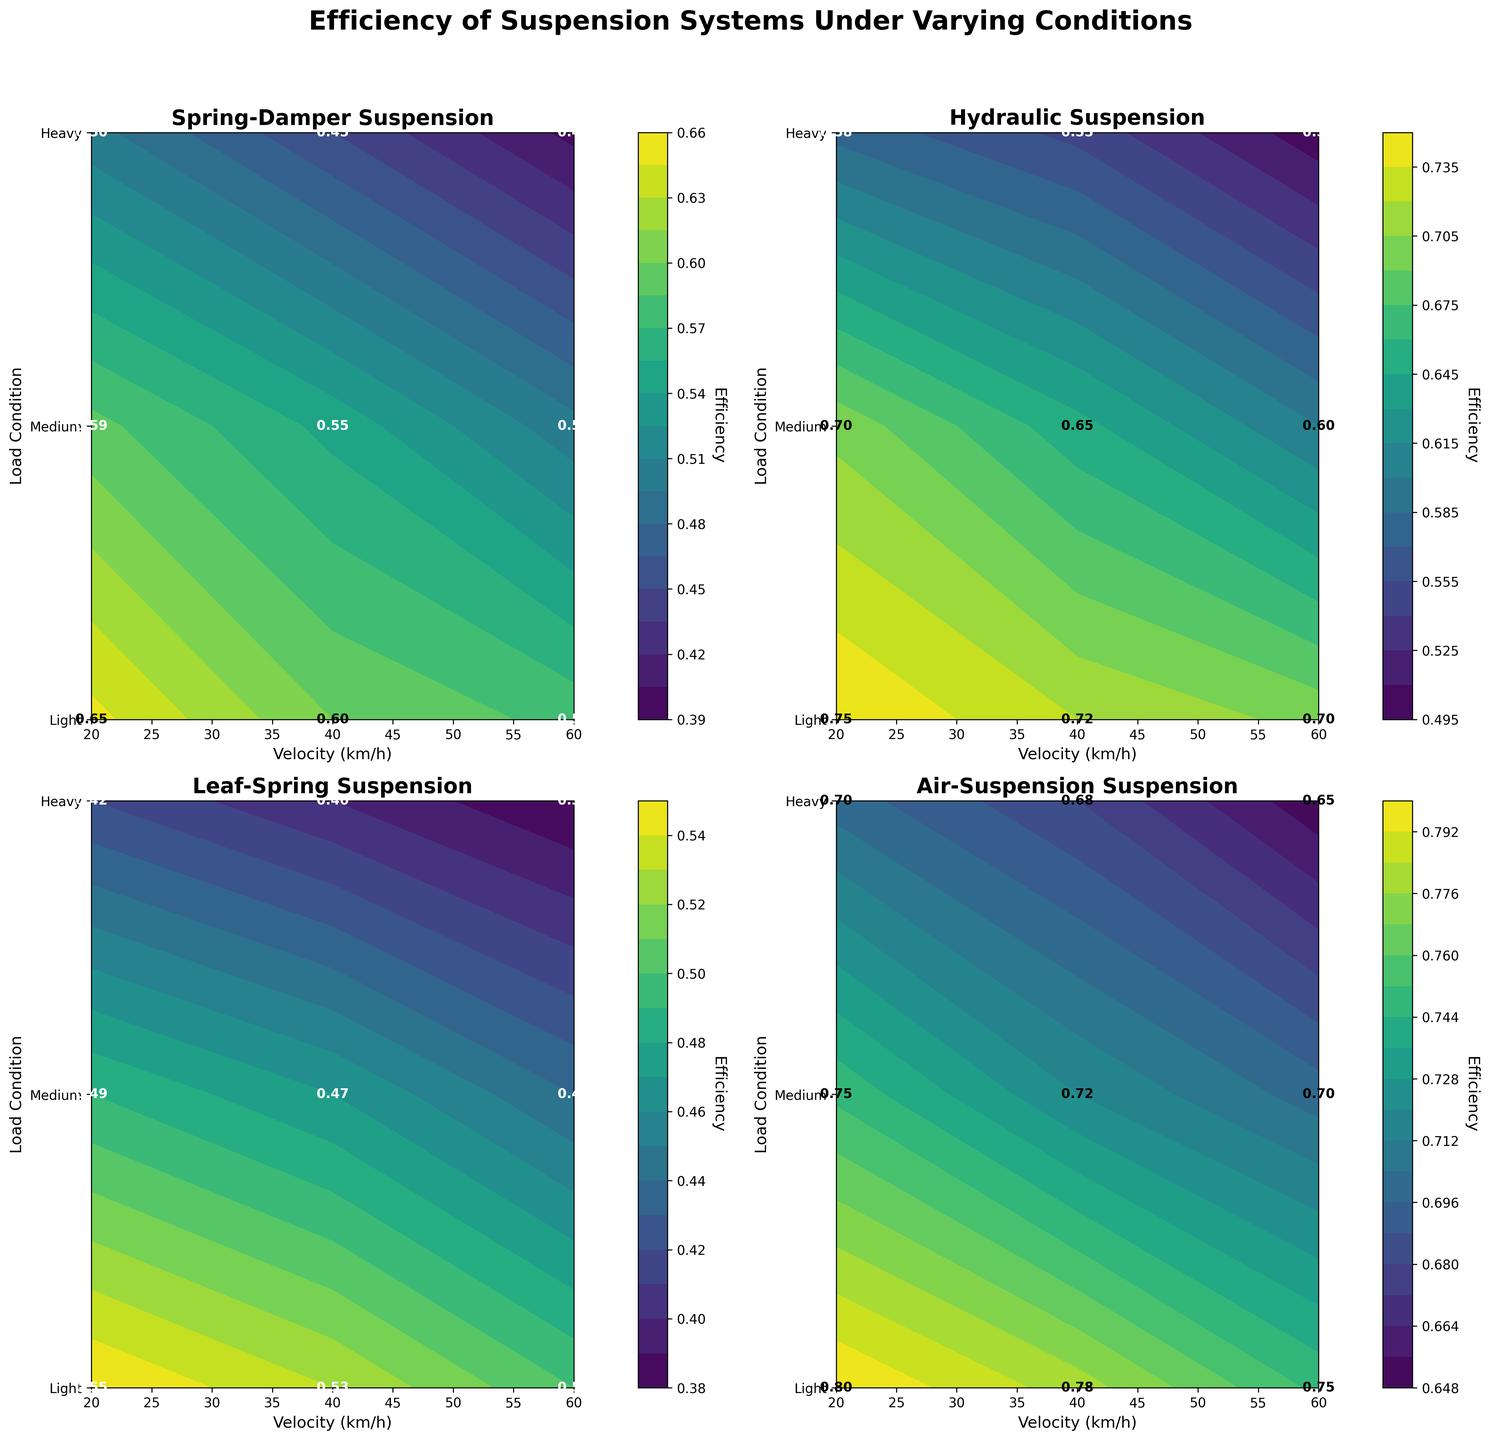what is the title of the figure? The title is located at the very top of the figure, displaying the main subject being studied. It reads 'Efficiency of Suspension Systems Under Varying Conditions'.
Answer: Efficiency of Suspension Systems Under Varying Conditions Which suspension system achieves the highest maximum efficiency? By examining the highest efficiency values across the subplots, the 'Air-Suspension' system has the highest maximum efficiency value of 0.80 under light load at a velocity of 20 km/h.
Answer: Air-Suspension At which load condition and velocity does the 'Leaf-Spring' system show its highest efficiency? Checking the 'Leaf-Spring' subplot, the highest efficiency is 0.55, occurring under light load condition at a velocity of 20 km/h.
Answer: Light load, 20 km/h How does the efficiency of the 'Spring-Damper' system change with increasing velocity under a medium load condition? In the 'Spring-Damper' subplot, under a medium load condition, the efficiency decreases as the velocity goes from 20 km/h (0.59) to 40 km/h (0.55) to 60 km/h (0.50).
Answer: It decreases Compare the efficiency of the 'Hydraulic' system under heavy load at 40 km/h and 60 km/h. Looking at the 'Hydraulic' subplot, the efficiency is 0.55 at 40 km/h and decreases to 0.50 at 60 km/h under a heavy load.
Answer: 0.55 at 40 km/h and 0.50 at 60 km/h Which suspension system maintains the highest efficiency at 60 km/h under medium load? By comparing the efficiencies, the 'Air-Suspension' system shows the highest efficiency value of 0.70 at 60 km/h under a medium load condition.
Answer: Air-Suspension What is the visual appearance of the contours for the 'Hydraulic' system compared to the 'Leaf-Spring' system in terms of smoothness and color transitions? The 'Hydraulic' system's contours are smoother with gradual color transitions, indicating less variation in efficiency, while the 'Leaf-Spring' system shows more abrupt transitions, suggesting higher variability.
Answer: 'Hydraulic' has smoother contours, 'Leaf-Spring' has abrupt transitions Rank the suspension systems from highest to lowest efficiency under light load at 40 km/h. Under light load at 40 km/h, the efficiencies are 'Air-Suspension' (0.78), 'Hydraulic' (0.72), 'Spring-Damper' (0.60), 'Leaf-Spring' (0.53).
Answer: Air-Suspension, Hydraulic, Spring-Damper, Leaf-Spring 